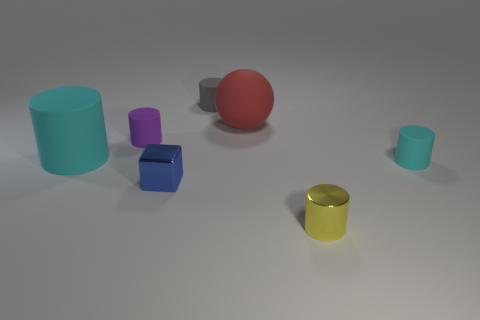Subtract all purple cylinders. How many cylinders are left? 4 Subtract all metallic cylinders. How many cylinders are left? 4 Subtract 2 cylinders. How many cylinders are left? 3 Subtract all brown cylinders. Subtract all green spheres. How many cylinders are left? 5 Add 3 small blue objects. How many objects exist? 10 Subtract all blocks. How many objects are left? 6 Subtract all tiny gray rubber things. Subtract all cyan rubber cylinders. How many objects are left? 4 Add 1 purple rubber objects. How many purple rubber objects are left? 2 Add 6 big cylinders. How many big cylinders exist? 7 Subtract 0 gray balls. How many objects are left? 7 